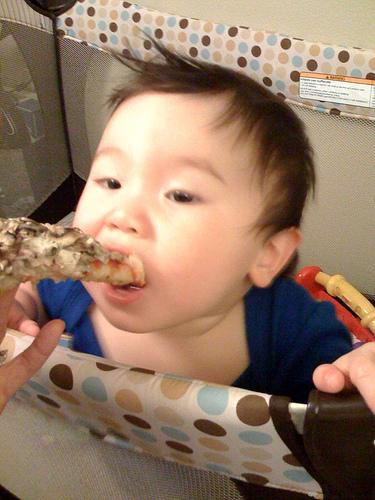What is the baby being fed?
Short answer required. Pizza. Is this a newborn baby?
Write a very short answer. No. Is the child standing or sitting?
Keep it brief. Standing. 